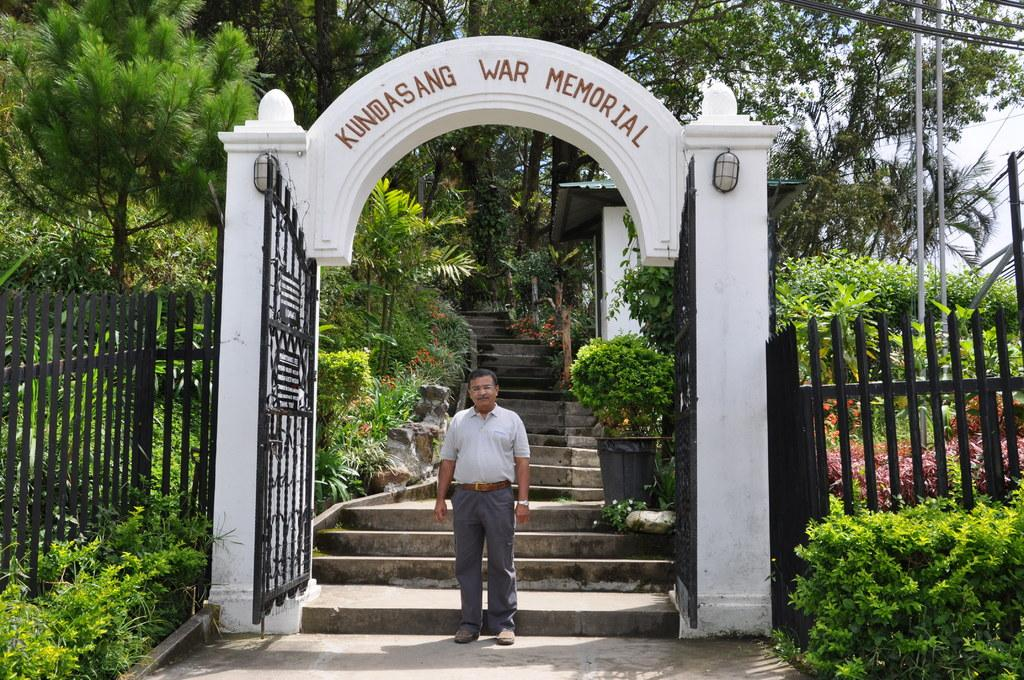What can be seen in the sky in the image? The sky is visible in the image. What structures are present in the image? There are poles and an arch in the image. What are the poles connected by? Cables are present in the image, connecting the poles. What type of vegetation can be seen in the image? Trees, bushes, and house plants are visible in the image. What is the person in the image doing? A person is standing on the floor in the image. What is the name of the place in the image? A name board is in the image, which may indicate the name of the place. What type of flower is growing on the prison bars in the image? There is no prison or flower present in the image. What is the person's opinion about the flower in the image? There is no flower or opinion present in the image. 